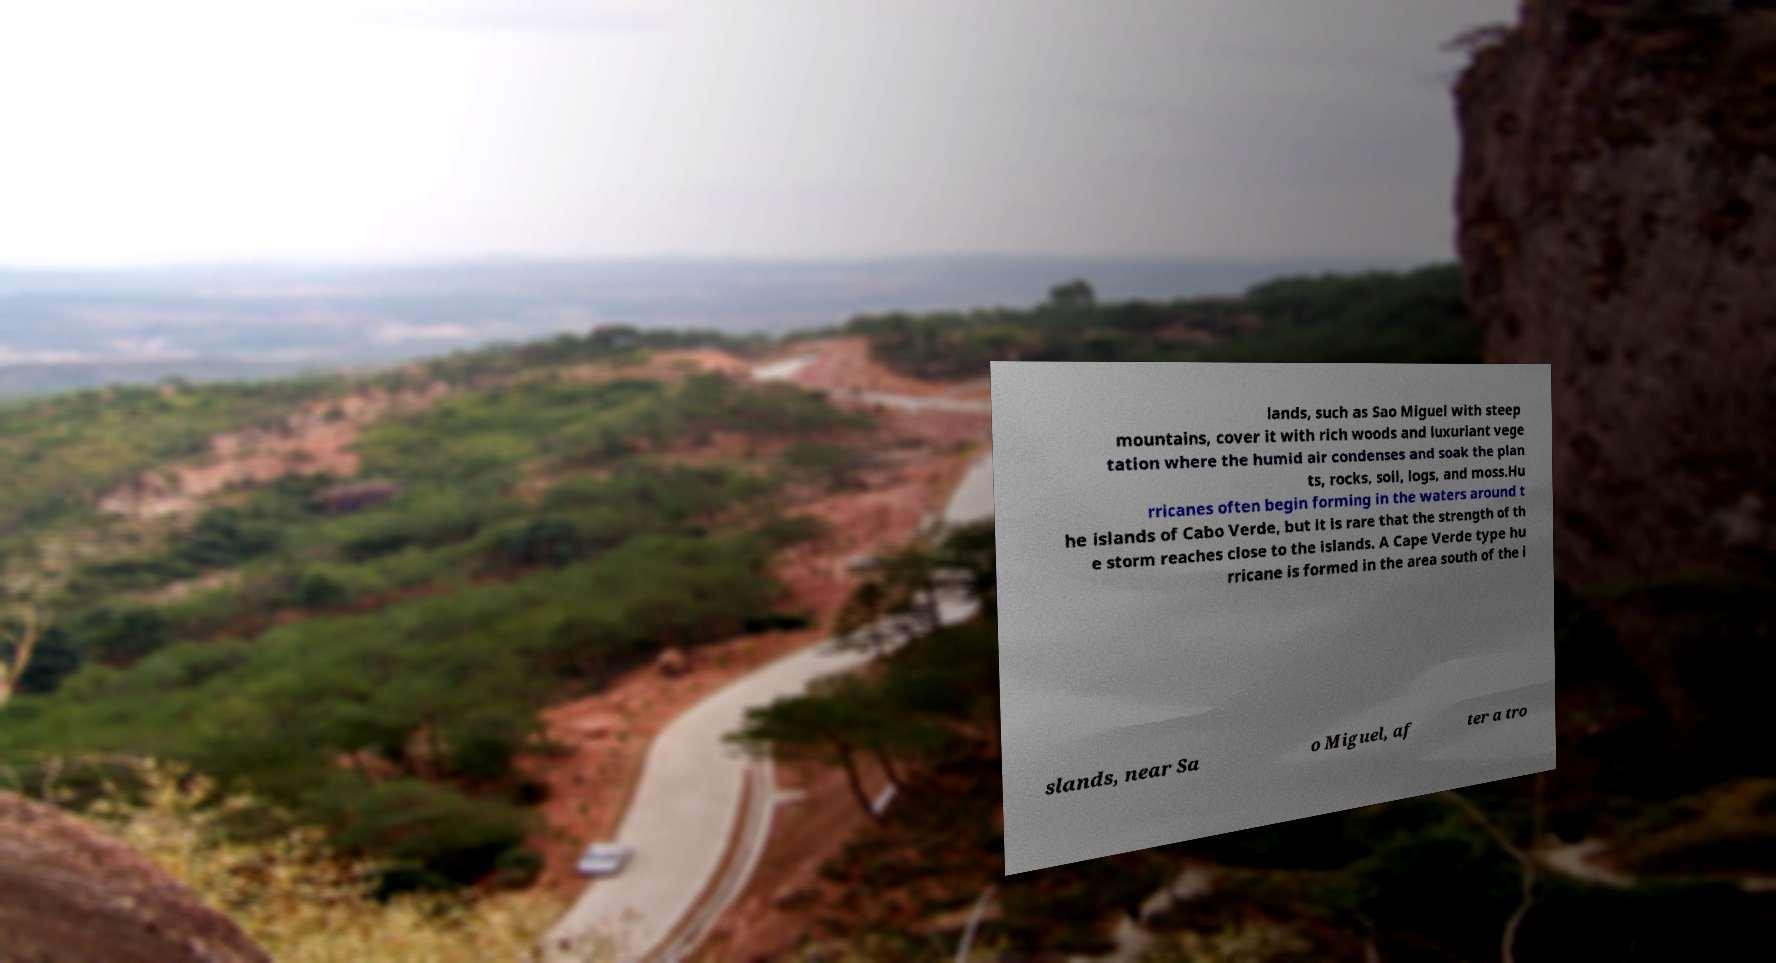Please identify and transcribe the text found in this image. lands, such as Sao Miguel with steep mountains, cover it with rich woods and luxuriant vege tation where the humid air condenses and soak the plan ts, rocks, soil, logs, and moss.Hu rricanes often begin forming in the waters around t he islands of Cabo Verde, but it is rare that the strength of th e storm reaches close to the islands. A Cape Verde type hu rricane is formed in the area south of the i slands, near Sa o Miguel, af ter a tro 